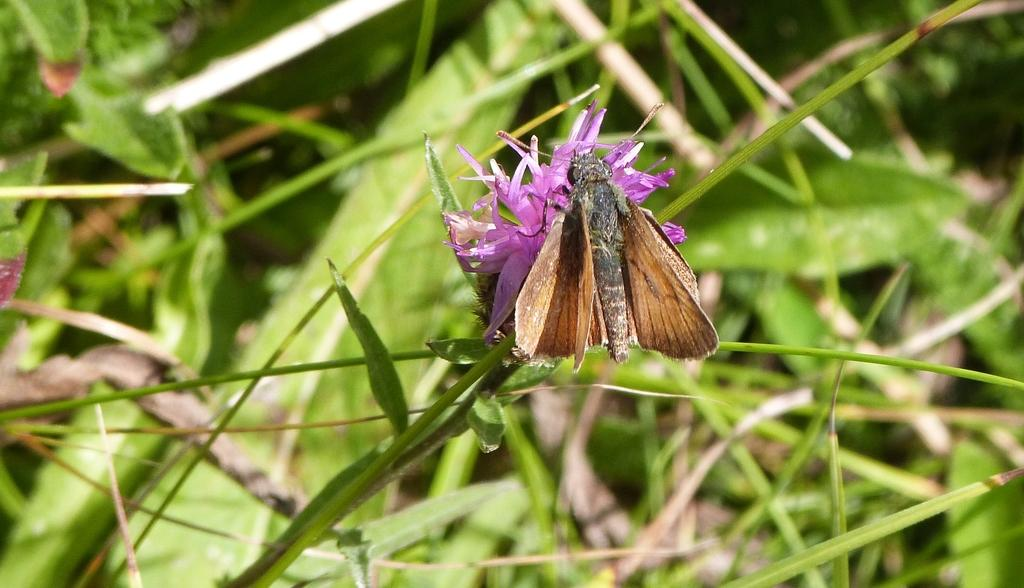What is on the flower in the image? There is a fly on a flower in the image. What type of vegetation is at the bottom of the image? There is grass at the bottom of the image. What can be seen in the background of the image? There are plants in the background of the image. What type of hospital can be seen in the background of the image? There is no hospital present in the image; it features a fly on a flower, grass at the bottom, and plants in the background. What kind of toys are scattered around the zebra in the image? There is no zebra or toys present in the image. 